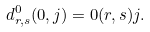Convert formula to latex. <formula><loc_0><loc_0><loc_500><loc_500>d ^ { 0 } _ { r , s } ( 0 , j ) = 0 ( r , s ) j .</formula> 